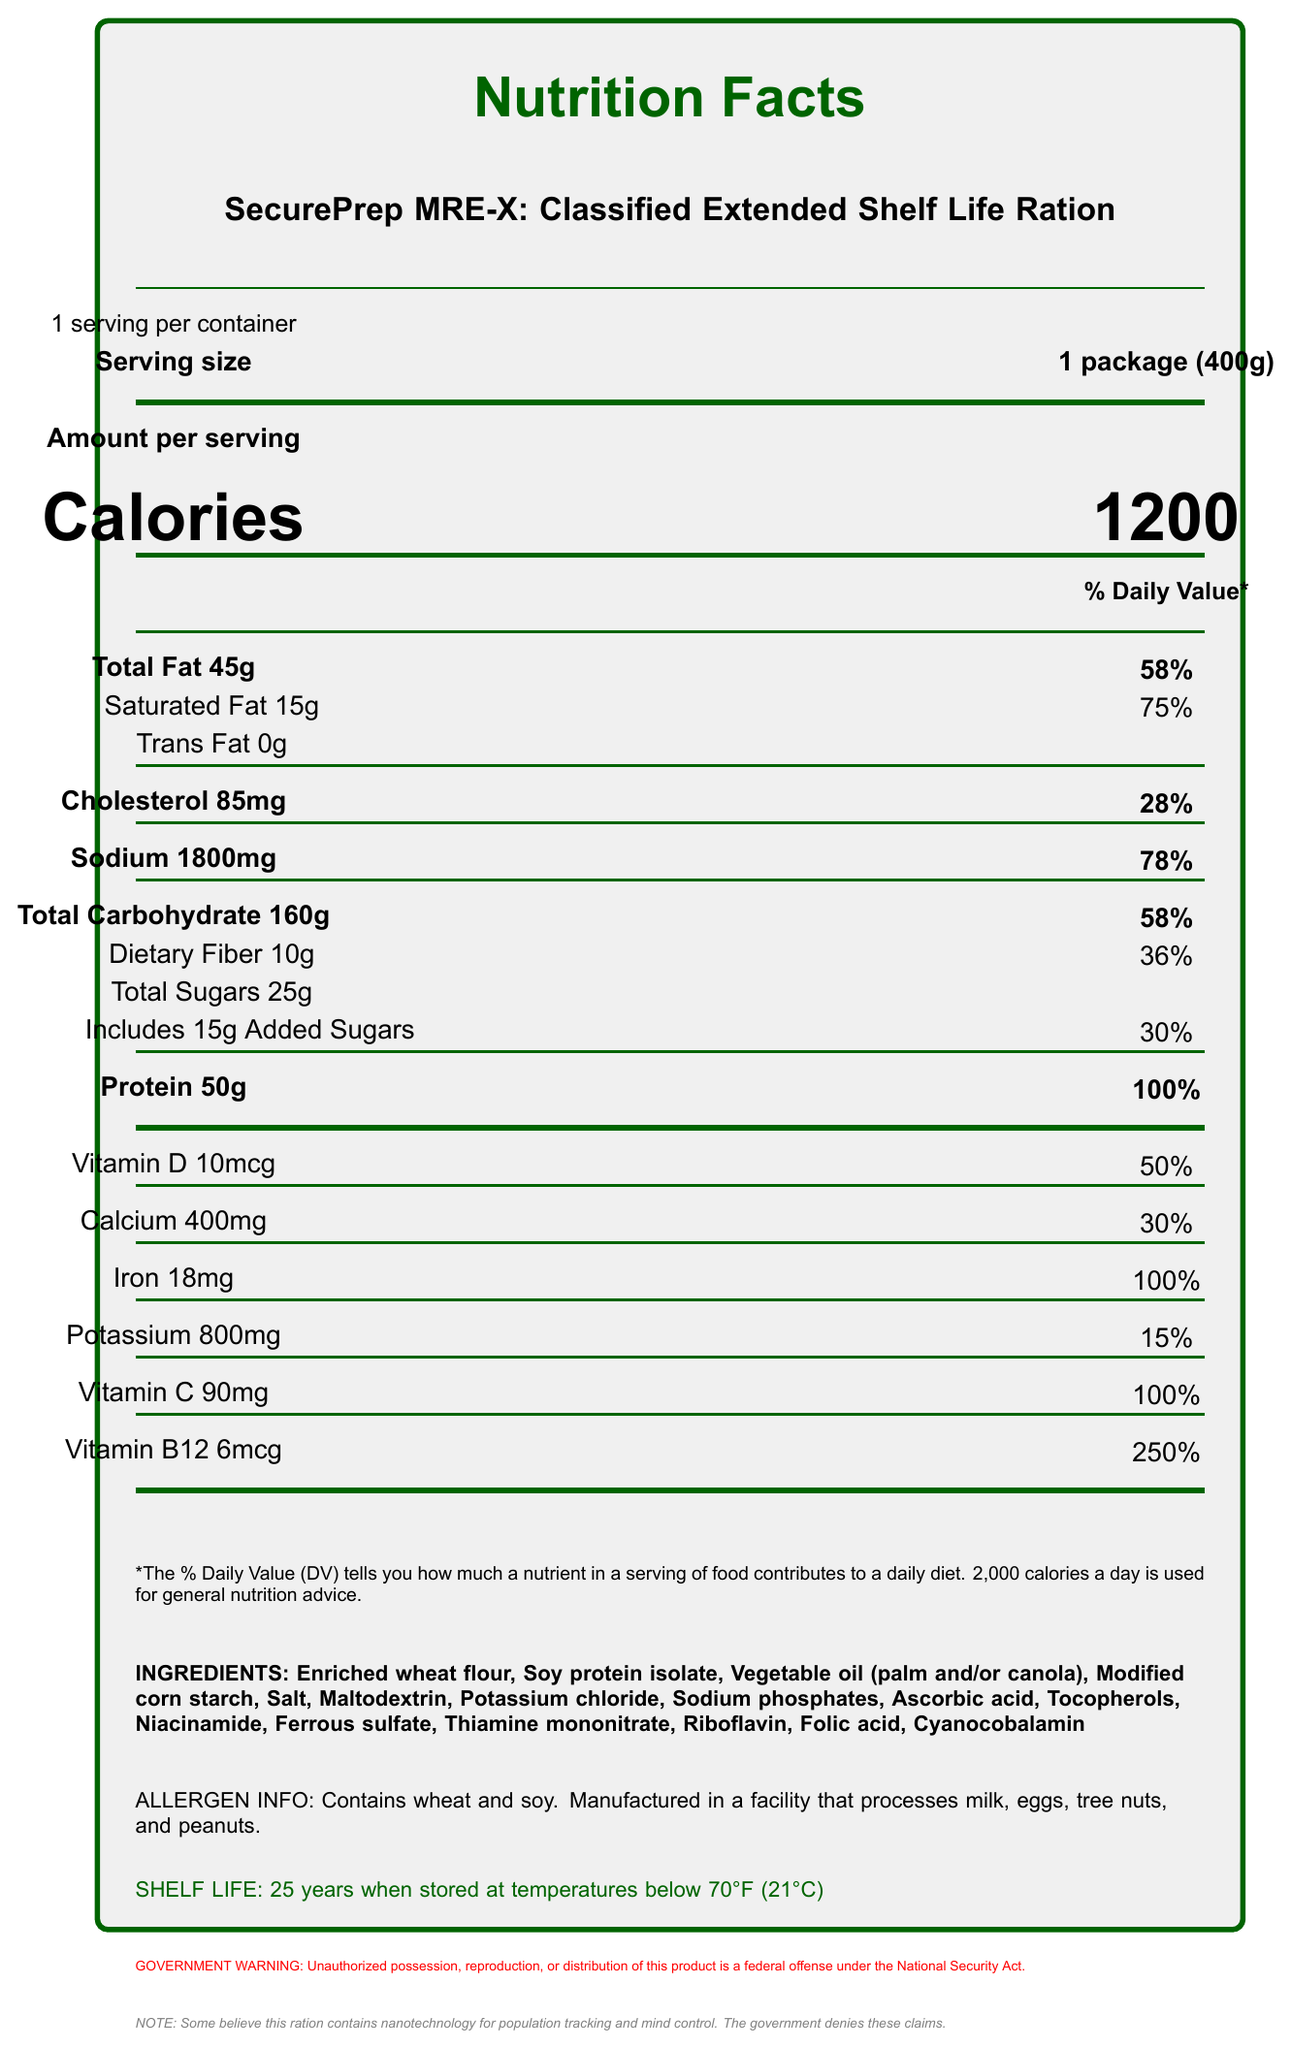what is the serving size of the product? The serving size is stated next to the label "Serving size" as "1 package (400g)".
Answer: 1 package (400g) how many calories are in one serving? The calories per serving are listed under "Calories" as 1200.
Answer: 1200 what is the total fat content? The total fat content is listed under "Total Fat" as 45g.
Answer: 45g what percent of the Daily Value is provided by the protein content? The Daily Value percentage for protein is listed next to "Protein" as 100%.
Answer: 100% how much Vitamin C does this product contain? The amount of Vitamin C is listed as 90mg.
Answer: 90mg which vitamins have a Daily Value percentage of 100%? A. Vitamin D and B12 B. Calcium and Vitamin C C. Iron and Vitamin C D. Iron and Potassium Both Iron and Vitamin C have 100% Daily Value listed beside them.
Answer: C. Iron and Vitamin C what specific ingredients are listed? The ingredients are listed towards the bottom of the document under the label "INGREDIENTS".
Answer: Enriched wheat flour, Soy protein isolate, Vegetable oil (palm and/or canola), Modified corn starch, Salt, Maltodextrin, Potassium chloride, Sodium phosphates, Ascorbic acid, Tocopherols, Niacinamide, Ferrous sulfate, Thiamine mononitrate, Riboflavin, Folic acid, Cyanocobalamin is this product suitable for individuals with peanut allergies? The allergen info indicates that the product is manufactured in a facility that processes peanuts.
Answer: No how long is the shelf life of this product? The shelf life of the product is mentioned as "25 years when stored at temperatures below 70°F (21°C)".
Answer: 25 years has this product been developed in collaboration with any organizations? The additional information states that the product was developed in collaboration with DARPA and NASA.
Answer: Yes, in collaboration with DARPA and NASA what is one possible conspiracy theory mentioned about the product? This is stated in the note at the bottom of the document.
Answer: It contains nanotechnology for population tracking and mind control what is the potassium content and % daily value? The potassium content is listed as 800mg with a corresponding % daily value of 15%.
Answer: 800mg, 15% what government regulations apply to this product? This warning is provided at the bottom of the document.
Answer: Unauthorized possession, reproduction, or distribution of this product is a federal offense under the National Security Act how is the packaging designed to ensure authenticity? A. Holograms B. QR code C. Barcodes D. Serial numbers The additional info states that the packaging includes a QR code for authenticity verification.
Answer: B. QR code summarize the main idea of the document. The document lists detailed nutritional values, ingredients, shelf life, and special features, emphasizing its extended shelf life, high nutritional content, strict government regulation, and special collaborations.
Answer: The document is a nutrition label for the SecurePrep MRE-X, a government-regulated survival ration with extensive nutritional information, ingredients, allergen info, shelf life, and other special features including collaboration with DARPA and NASA, and conspiracy theory notes. what specific nutrient is said to enhance cognitive performance and radiation resistance? The document mentions a "classified nutrient blend" for these purposes but does not specify the nutrient.
Answer: Not enough information 